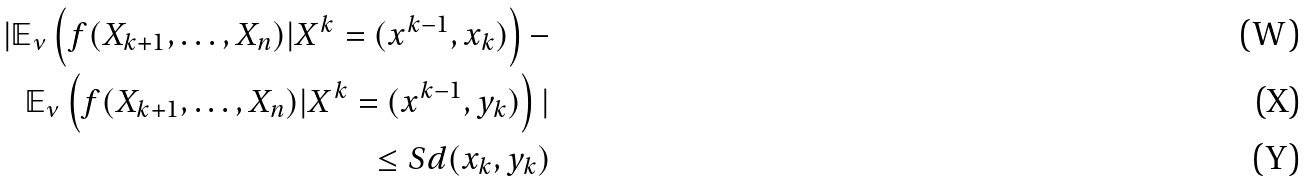Convert formula to latex. <formula><loc_0><loc_0><loc_500><loc_500>| \mathbb { E } _ { \nu } \left ( f ( X _ { k + 1 } , \dots , X _ { n } ) | X ^ { k } = ( x ^ { k - 1 } , x _ { k } ) \right ) - \\ \mathbb { E } _ { \nu } \left ( f ( X _ { k + 1 } , \dots , X _ { n } ) | X ^ { k } = ( x ^ { k - 1 } , y _ { k } ) \right ) | \\ \leq S d ( x _ { k } , y _ { k } )</formula> 